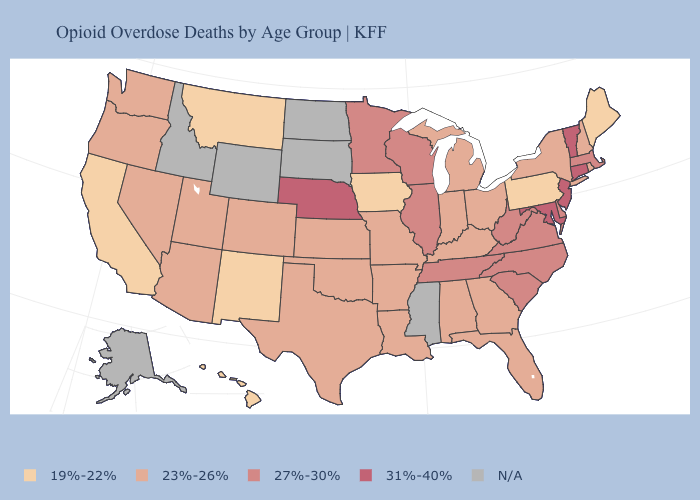Does the map have missing data?
Give a very brief answer. Yes. What is the value of Idaho?
Answer briefly. N/A. Which states have the lowest value in the MidWest?
Short answer required. Iowa. Which states have the lowest value in the Northeast?
Answer briefly. Maine, Pennsylvania. Name the states that have a value in the range 27%-30%?
Give a very brief answer. Delaware, Illinois, Massachusetts, Minnesota, North Carolina, South Carolina, Tennessee, Virginia, West Virginia, Wisconsin. Does Nebraska have the highest value in the MidWest?
Short answer required. Yes. What is the value of Utah?
Keep it brief. 23%-26%. Name the states that have a value in the range 31%-40%?
Concise answer only. Connecticut, Maryland, Nebraska, New Jersey, Vermont. What is the value of Kentucky?
Keep it brief. 23%-26%. Among the states that border Arkansas , which have the lowest value?
Give a very brief answer. Louisiana, Missouri, Oklahoma, Texas. Name the states that have a value in the range 31%-40%?
Write a very short answer. Connecticut, Maryland, Nebraska, New Jersey, Vermont. What is the value of Montana?
Answer briefly. 19%-22%. Among the states that border Maryland , which have the highest value?
Write a very short answer. Delaware, Virginia, West Virginia. 